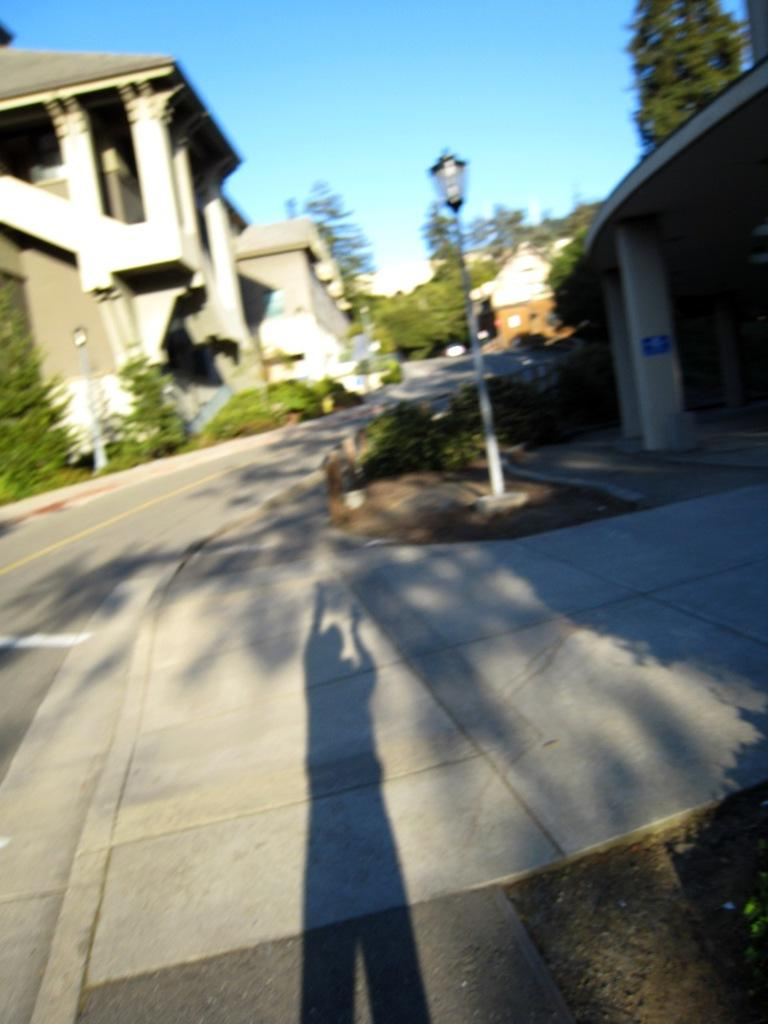What type of structure can be seen in the image? There is a building in the image. What is another object visible in the image? There is a light pole in the image. What type of vegetation is present in the image? There is grass and a tree in the image. What architectural feature can be seen in the image? There is a pillar in the image. What part of the natural environment is visible in the image? The sky is visible in the image. What man-made feature is present in the image? There is a road in the image. Is there any indication of a person's presence in the image? Yes, there is a shadow of a person in the image. What type of toothbrush is being used by the person in the image? There is no toothbrush present in the image, as it only shows a shadow of a person. What day is it in the image? The day cannot be determined from the image, as it only shows a shadow of a person and does not provide any context about the time or date. 